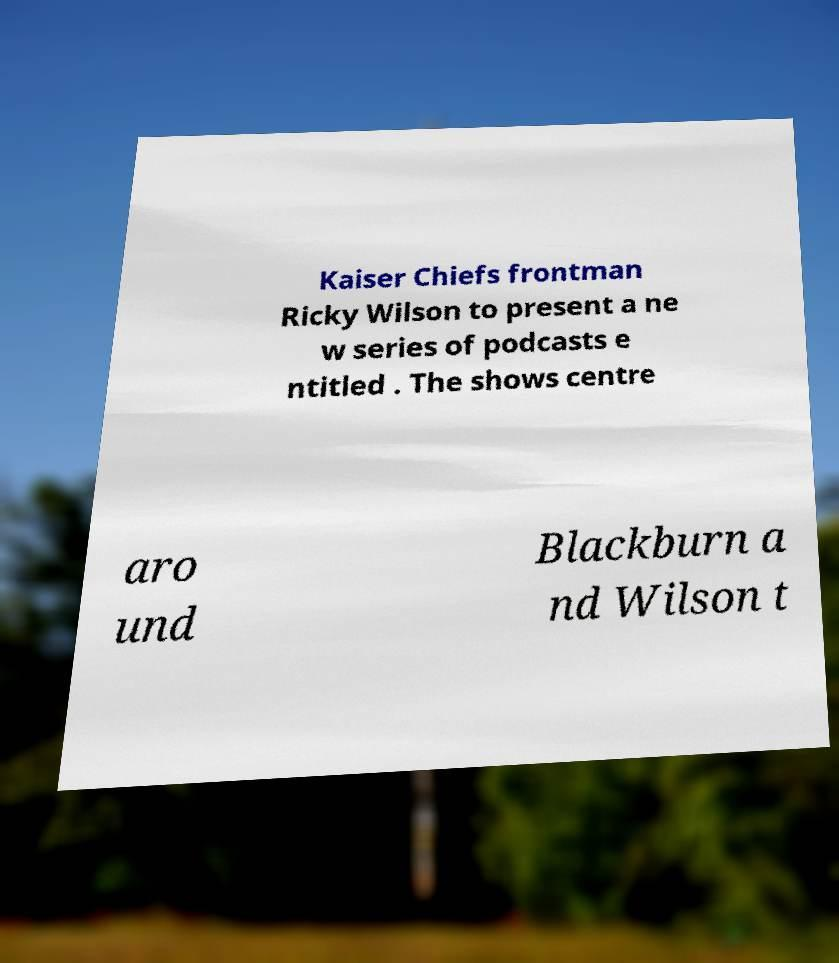Please identify and transcribe the text found in this image. Kaiser Chiefs frontman Ricky Wilson to present a ne w series of podcasts e ntitled . The shows centre aro und Blackburn a nd Wilson t 